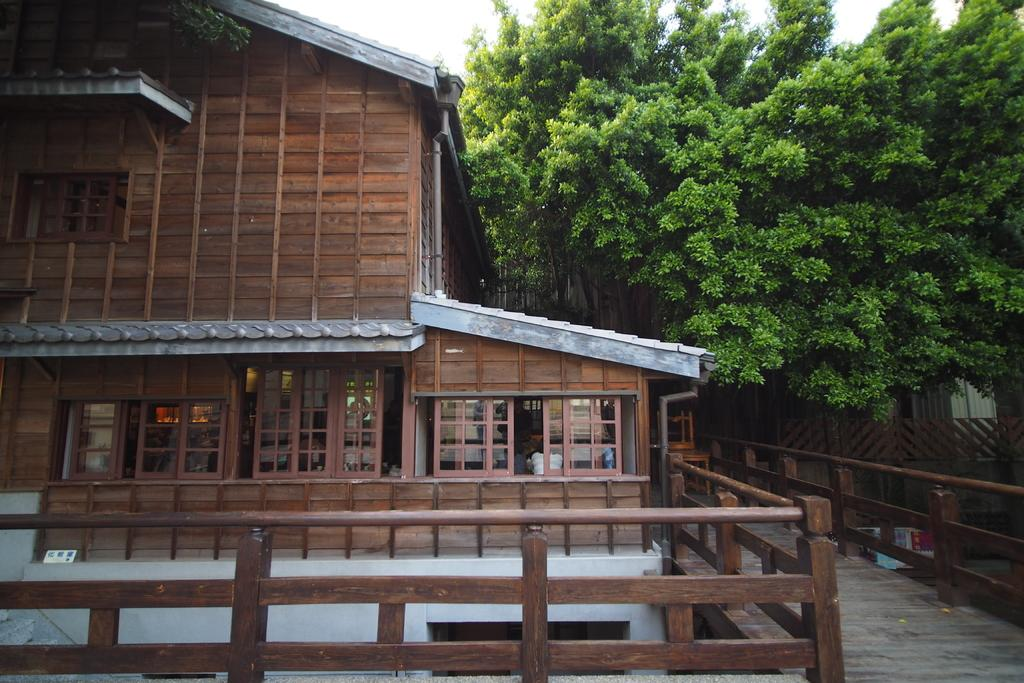What type of structure is visible in the image? There is a house in the image. Who or what can be seen inside the house? There are people in the house. What can be seen in the distance behind the house? There are trees in the background of the image. What type of barrier is present in the background of the image? There is a wooden fence in the background of the image. What type of watch is the passenger wearing in the image? There is no passenger or watch present in the image. 